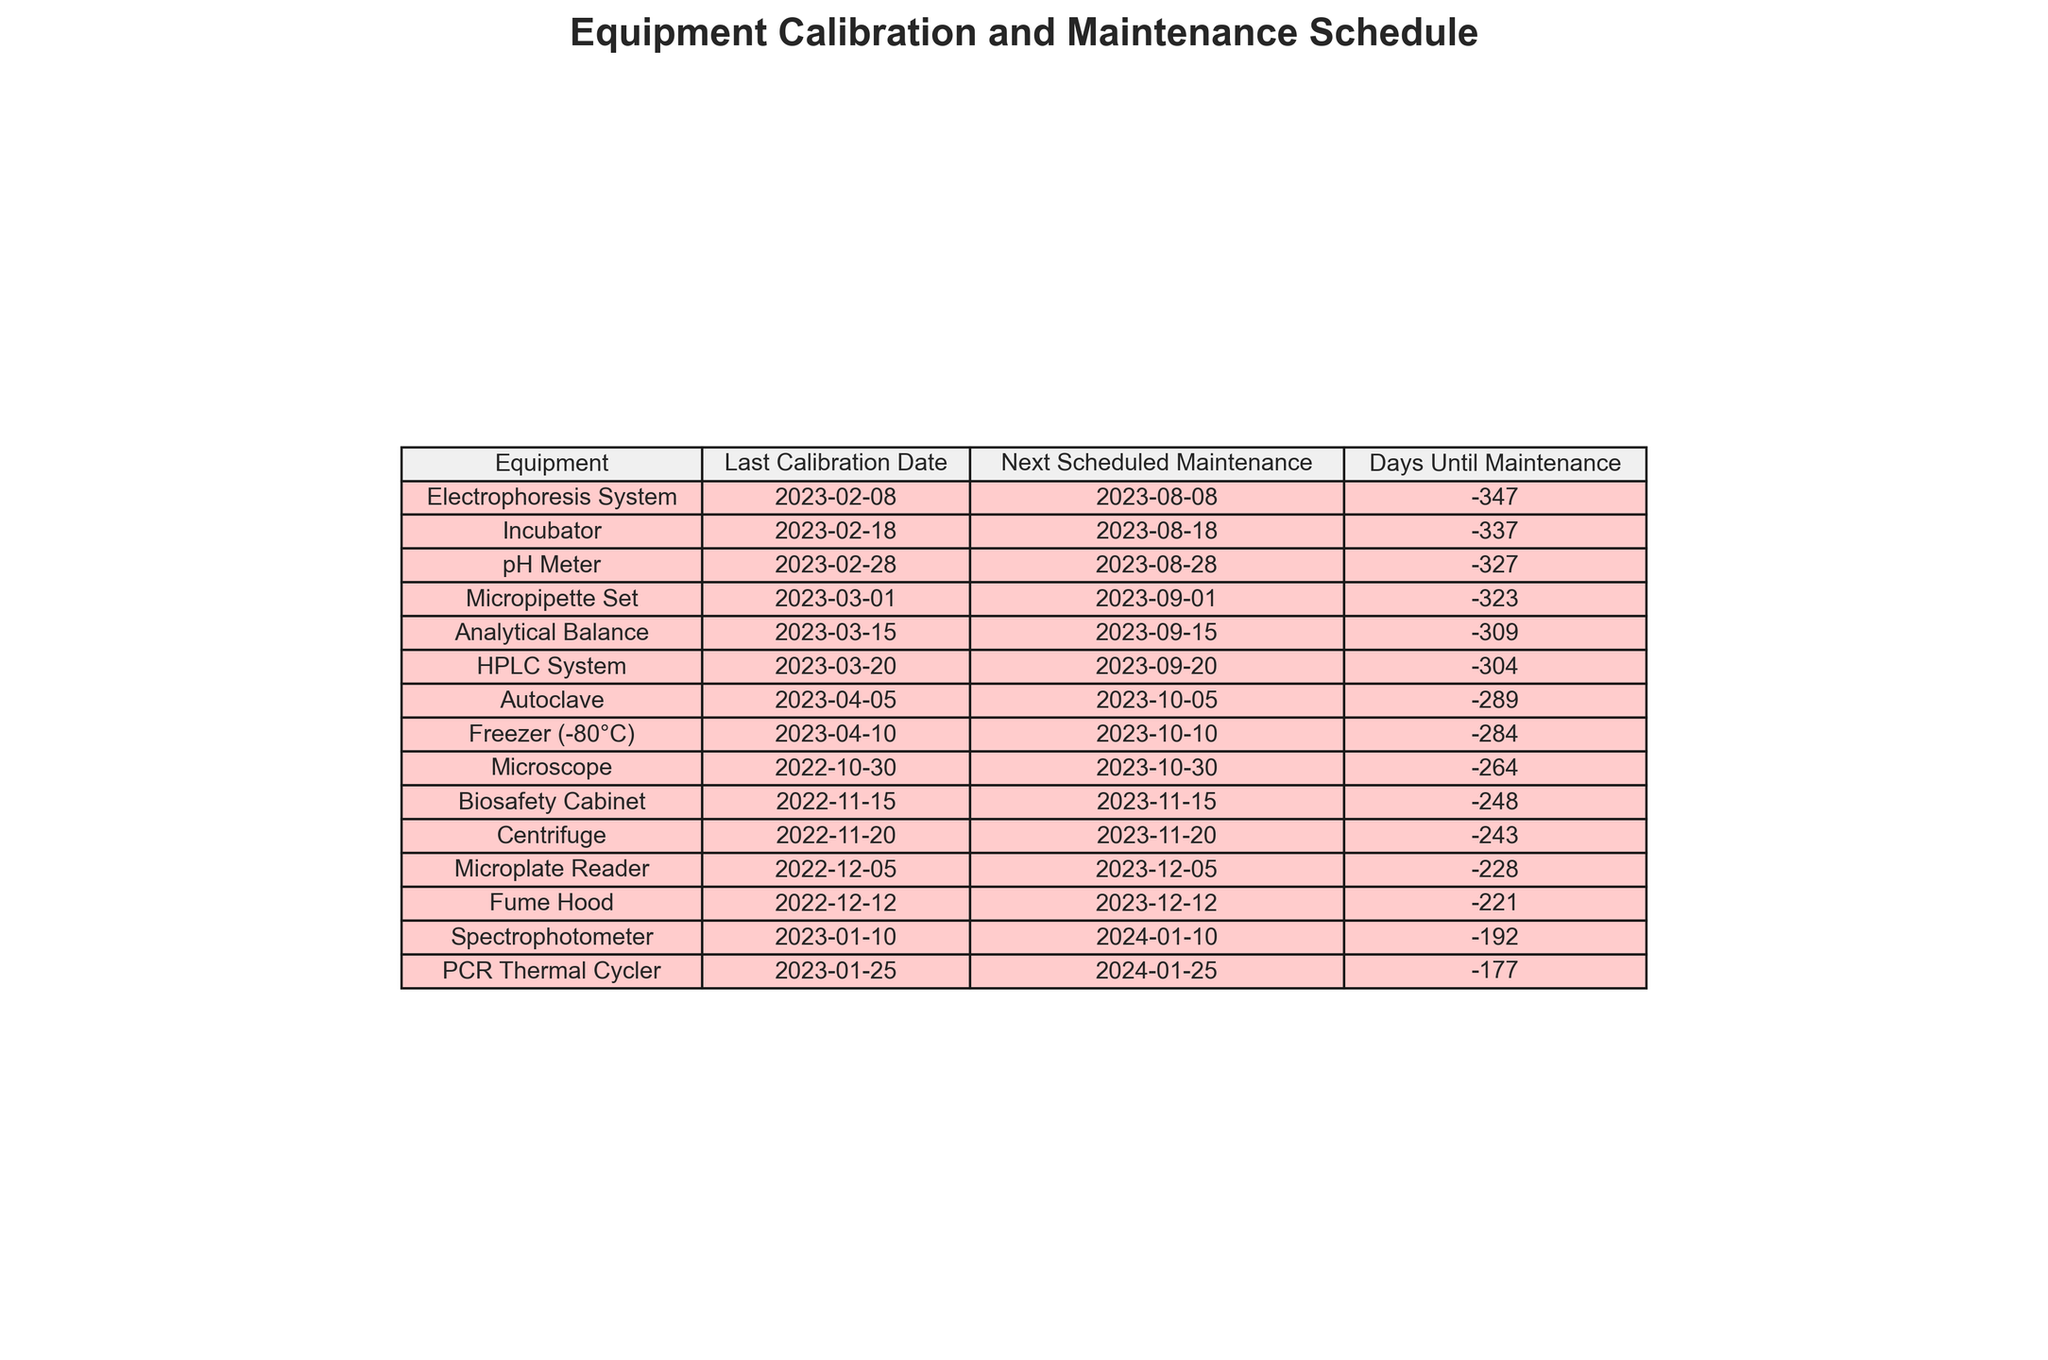What is the last calibration date for the Incubator? The last calibration date for the Incubator is specifically listed in the table under the corresponding column, which shows "2023-02-18".
Answer: 2023-02-18 When is the next scheduled maintenance for the pH Meter? The next scheduled maintenance date for the pH Meter can be found in the table under its respective row, and it states "2023-08-28".
Answer: 2023-08-28 Which equipment requires maintenance the soonest? By examining the "Days Until Maintenance" column, we can identify that the equipment with the lowest value requires maintenance the soonest. In this case, it is the "Analytical Balance" with 1 day.
Answer: Analytical Balance Is there any equipment that is due for maintenance in the next month? By reviewing the "Days Until Maintenance" column for values less than 30, we find that both the "Analytical Balance" and "pH Meter" are due for maintenance soon, within the next month.
Answer: Yes How many pieces of equipment are scheduled for maintenance in October 2023? We can look at the "Next Scheduled Maintenance" column to see which entries list October 2023. In total, there are 3 pieces of equipment scheduled for maintenance in that month: "Autoclave," "Freezer (-80°C)," and "Micropipette Set."
Answer: 3 What is the average number of days until maintenance for all equipment? First, we would sum the values of "Days Until Maintenance" for each piece of equipment, then divide by the number of equipment entries. The sum is 243 days (summing up all entries), and with 15 pieces of equipment, the average is 243/15 = 16.2 days.
Answer: 16.2 days Which equipment has the farthest next scheduled maintenance date? To find the equipment with the farthest next scheduled maintenance date, we can look for the maximum date listed in the "Next Scheduled Maintenance" column, which shows "2024-01-10" for the "Spectrophotometer."
Answer: Spectrophotometer Is the pH Meter's last calibration date more recent than the Centrifuge's? By comparing the last calibration dates from both the "pH Meter" and "Centrifuge," we see that the pH Meter's last calibration date is "2023-02-28", while the Centrifuge's is "2022-11-20", thus making the pH Meter's date more recent.
Answer: Yes What percentage of the equipment has been calibrated in 2023? We can determine the number of pieces of equipment calibrated in 2023 by counting the relevant entries. There are 10 out of 15 pieces of equipment calibrated in 2023, which gives us a percentage of (10/15) * 100 = 66.67%.
Answer: 66.67% Are there any two pieces of equipment scheduled for maintenance on the same day? By reviewing the "Next Scheduled Maintenance" dates, we can observe if any two entries match. In this case, the "Microplate Reader" and "Fume Hood" both have "2023-12-05" as their maintenance date, confirming they are scheduled for the same day.
Answer: Yes 